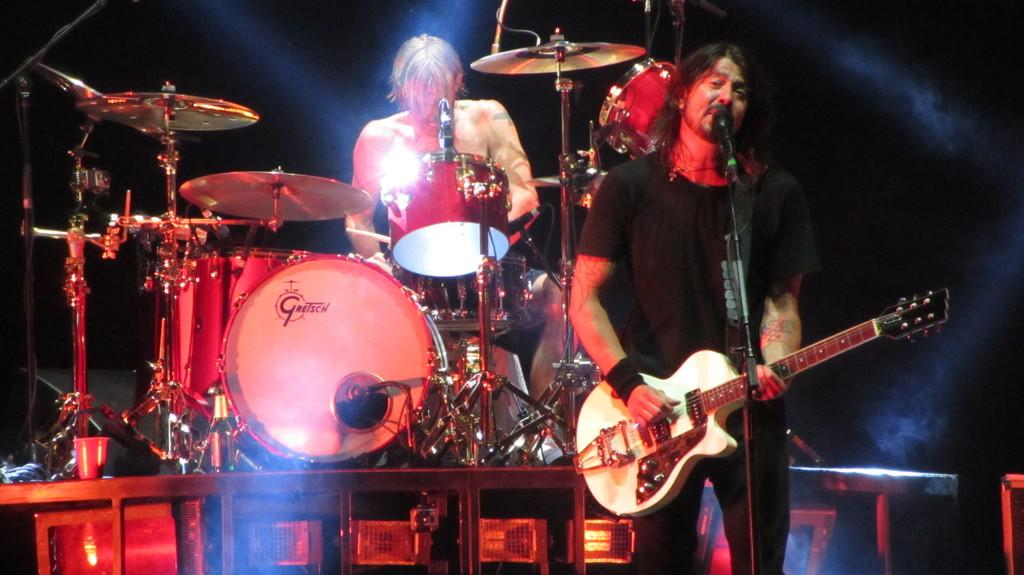How many people are in the image? There are two people in the image. What is one person doing in the image? One person is standing and holding a guitar. What is the other person doing in the image? The other person is sitting next to a drum set. What object is in front of the person sitting next to the drum set? There is a microphone in front of the person sitting next to the drum set. What type of head of lettuce can be seen growing in the image? There is no head of lettuce present in the image; it features two people with musical instruments and a microphone. Is there any steam visible coming from the drum set in the image? No, there is no steam visible coming from the drum set in the image. 